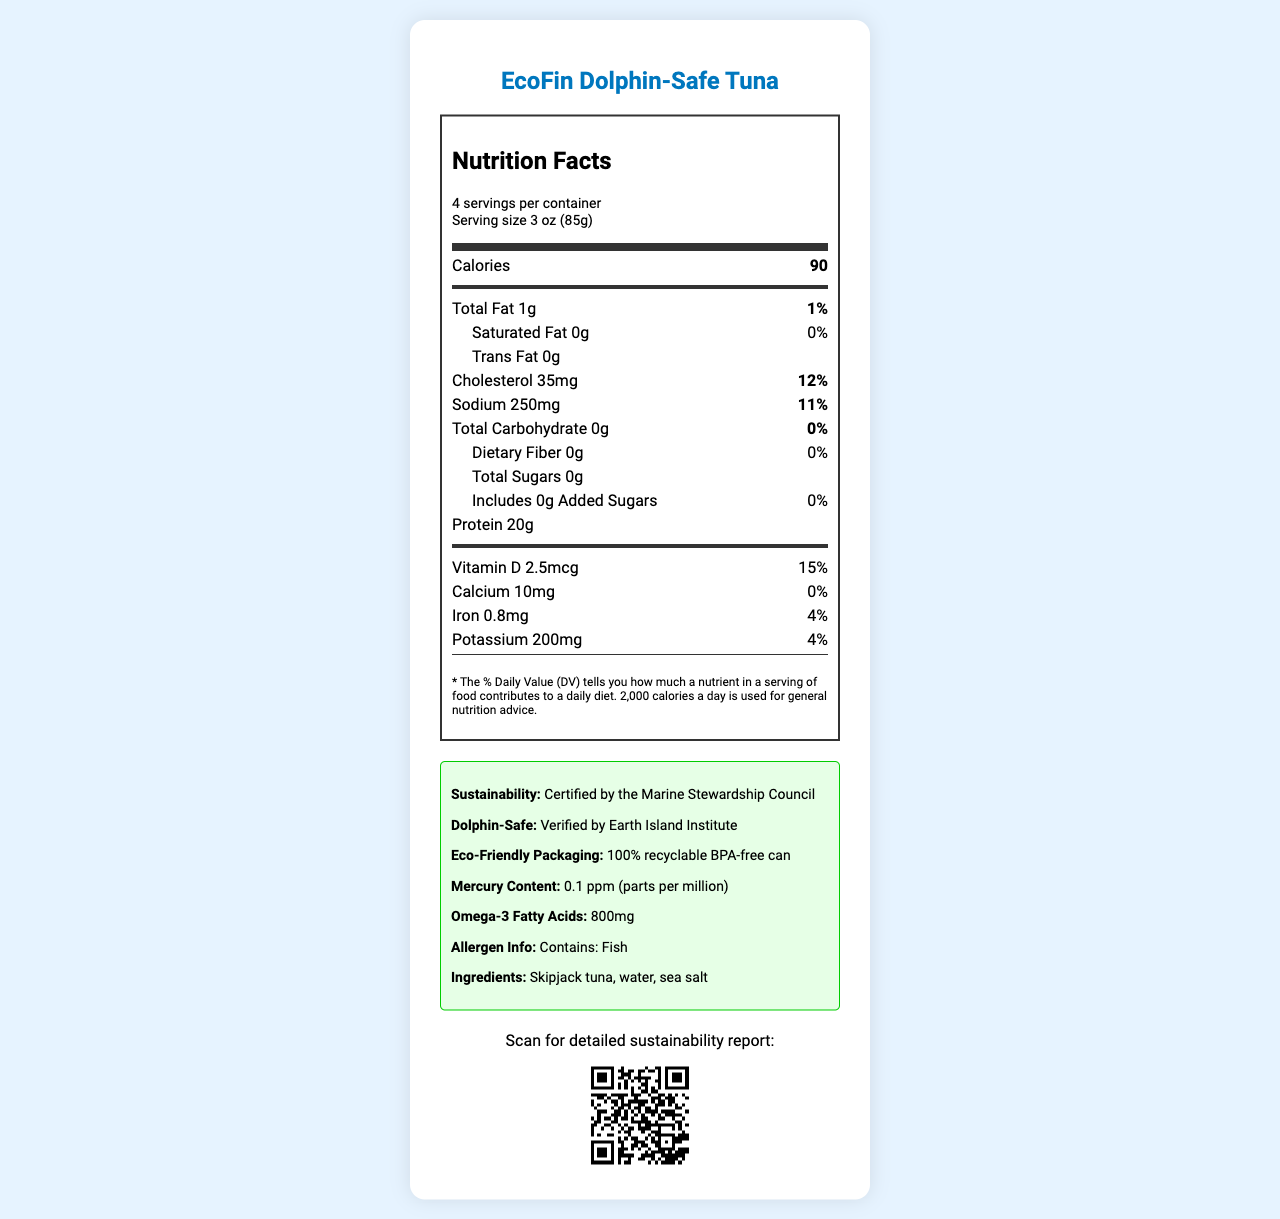what is the serving size of the EcoFin Dolphin-Safe Tuna? The serving size is mentioned as "3 oz (85g)" in the document.
Answer: 3 oz (85g) how many servings are there per container? The document states that there are 4 servings per container.
Answer: 4 what is the calorie count per serving? The calorie count per serving is listed as 90 in the document.
Answer: 90 how much saturated fat is there per serving? The document shows that there is 0g of saturated fat per serving.
Answer: 0g what amount of sodium is present per serving? The sodium content per serving is indicated as 250mg.
Answer: 250mg does the product contain any added sugars? The document shows 0g of added sugars, hence the product contains no added sugars.
Answer: No is the packaging eco-friendly? The document mentions that the packaging is "100% recyclable BPA-free can," which qualifies as eco-friendly.
Answer: Yes how much protein does each serving provide? The protein content per serving is listed as 20g in the document.
Answer: 20g what is the mercury content in the EcoFin Dolphin-Safe Tuna? The mercury content is mentioned as 0.1 ppm in the document.
Answer: 0.1 ppm (parts per million) what certification verifies the product as dolphin-safe? The dolphin-safe info is provided as "Verified by Earth Island Institute" in the document.
Answer: Verified by Earth Island Institute how much Vitamin D is in each serving of the tuna? The document specifies that each serving contains 2.5mcg of Vitamin D.
Answer: 2.5mcg how much potassium is there in each serving? The potassium content per serving is stated as 200mg in the document.
Answer: 200mg which of the following is true about the product’s sustainability certification? A. Certified by Earth Island Institute B. Certified by Marine Stewardship Council C. Certified by both Earth Island Institute and Marine Stewardship Council The product is "Certified by the Marine Stewardship Council," as mentioned in the document.
Answer: B how much cholesterol is there per serving? A. 15mg B. 25mg C. 35mg D. 45mg The document lists 35mg of cholesterol per serving.
Answer: C is the product safe for people with fish allergies? The allergen info states "Contains: Fish," meaning it is not safe for people with fish allergies.
Answer: No does the document provide information about the omega-3 fatty acids content? It specifies that there are 800mg of omega-3 fatty acids per serving.
Answer: Yes describe the main idea of the document. The document lists various nutritional facts, including serving size, calorie count, fat, cholesterol, sodium, carbohydrates, protein, and vitamin content. Additionally, it includes details about the product’s sustainability, dolphin-safe certification, and packaging.
Answer: The main idea of the document is to provide comprehensive nutritional information for the EcoFin Dolphin-Safe Tuna, highlighting its low mercury content, eco-friendly packaging, and sustainability certifications. what is the source of the QR code image provided in the document? The QR code's source is not explicitly mentioned in the document; hence, it cannot be determined from the provided visual information.
Answer: Not enough information 